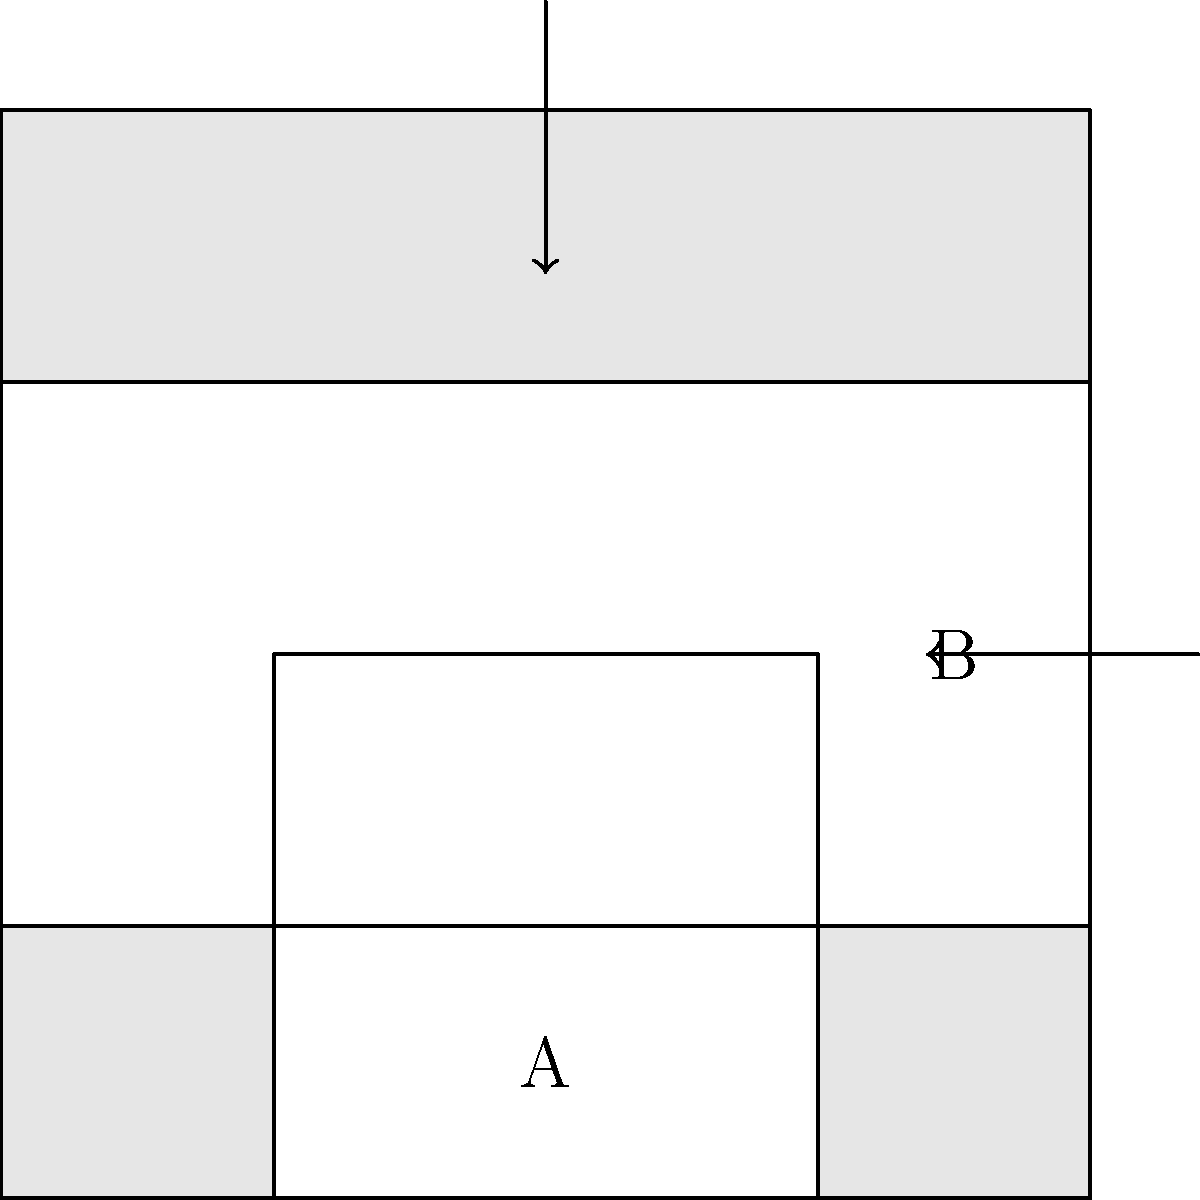In the diagram above, which represents a common interlocking wooden joint in traditional Indian architecture, what is the minimum number of topological holes created when parts A and B are fully interlocked? To determine the number of topological holes in this interlocking joint, we need to follow these steps:

1. Understand the structure: The joint consists of two interlocking pieces, A and B, that slide into each other.

2. Visualize the interlocked state: When fully interlocked, part A will slide upwards, and part B will slide to the left.

3. Identify potential holes: In the interlocked state, there will be two main areas where holes can form:
   a. The space created by part A sliding up into part B
   b. The space created by part B sliding left into part A

4. Count the holes: 
   - The space created by part A sliding up creates one hole through the joint.
   - The space created by part B sliding left creates another hole through the joint.

5. Consider the topology: From a topological perspective, these two holes are distinct and cannot be continuously deformed into each other without breaking the structure of the joint.

6. Final count: Therefore, the minimum number of topological holes created when the joint is fully interlocked is 2.

This type of joint, known as a mortise and tenon joint, is common in traditional Indian woodworking and architecture. Its interlocking nature provides strength and stability to the structure while also demonstrating the precision and attention to detail characteristic of Indian carpentry.
Answer: 2 